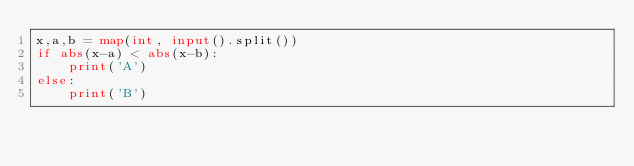Convert code to text. <code><loc_0><loc_0><loc_500><loc_500><_Python_>x,a,b = map(int, input().split())
if abs(x-a) < abs(x-b):
    print('A')
else:
    print('B')</code> 